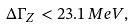<formula> <loc_0><loc_0><loc_500><loc_500>\Delta \Gamma _ { Z } < 2 3 . 1 \, M e V ,</formula> 